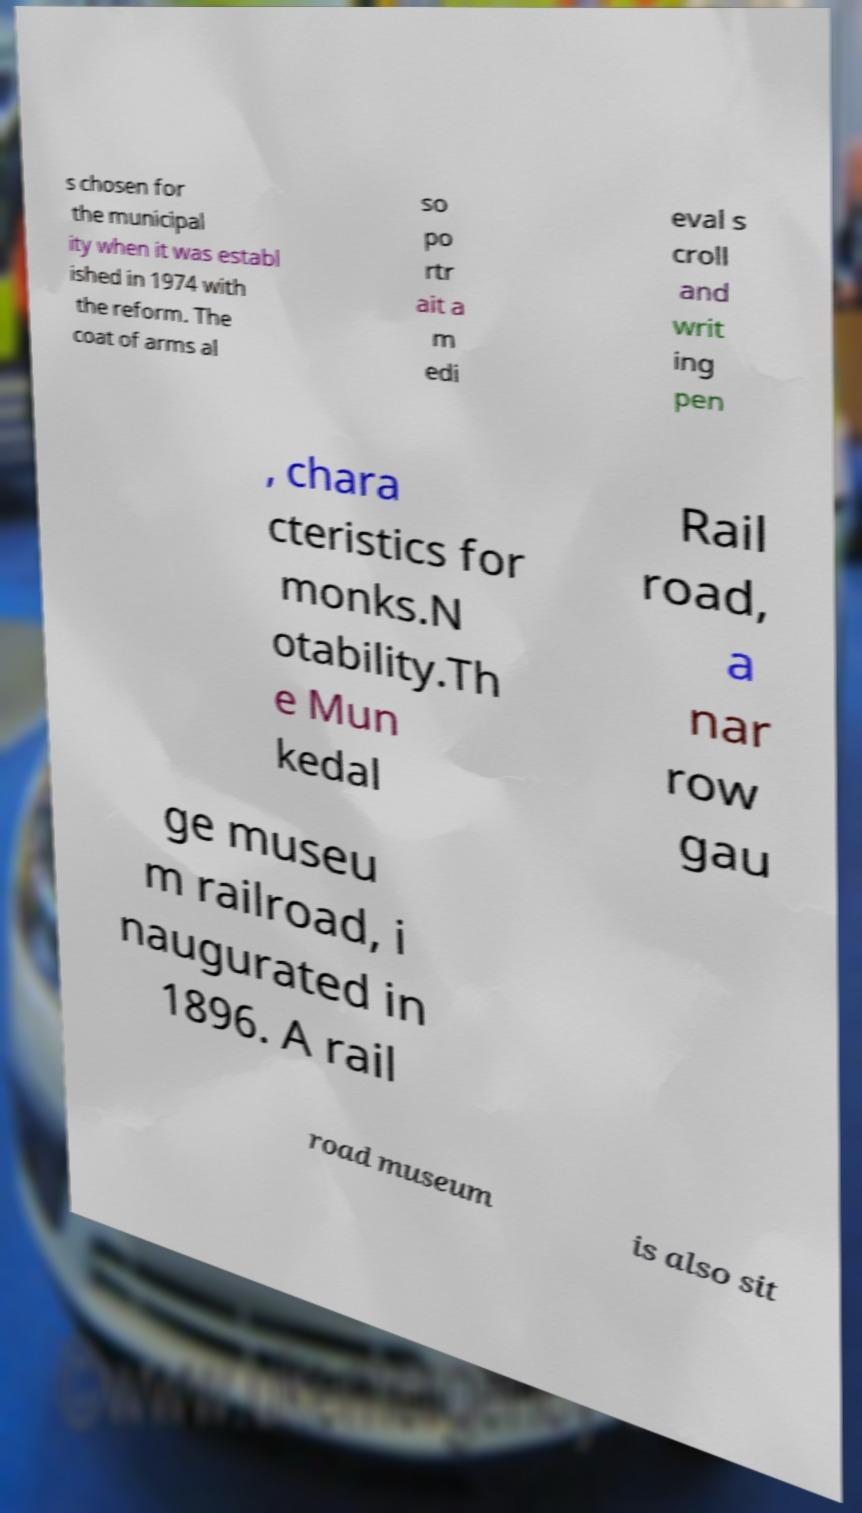Can you accurately transcribe the text from the provided image for me? s chosen for the municipal ity when it was establ ished in 1974 with the reform. The coat of arms al so po rtr ait a m edi eval s croll and writ ing pen , chara cteristics for monks.N otability.Th e Mun kedal Rail road, a nar row gau ge museu m railroad, i naugurated in 1896. A rail road museum is also sit 